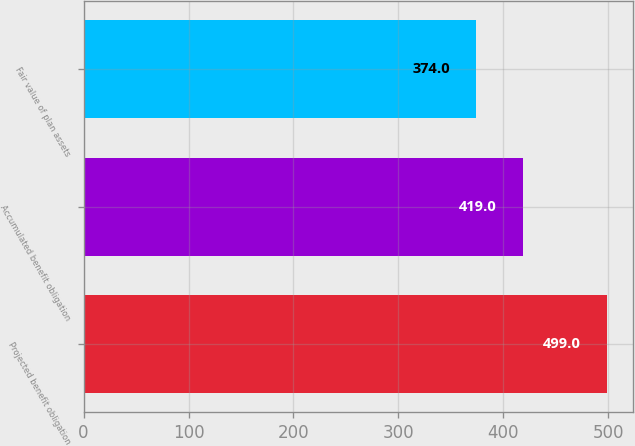<chart> <loc_0><loc_0><loc_500><loc_500><bar_chart><fcel>Projected benefit obligation<fcel>Accumulated benefit obligation<fcel>Fair value of plan assets<nl><fcel>499<fcel>419<fcel>374<nl></chart> 